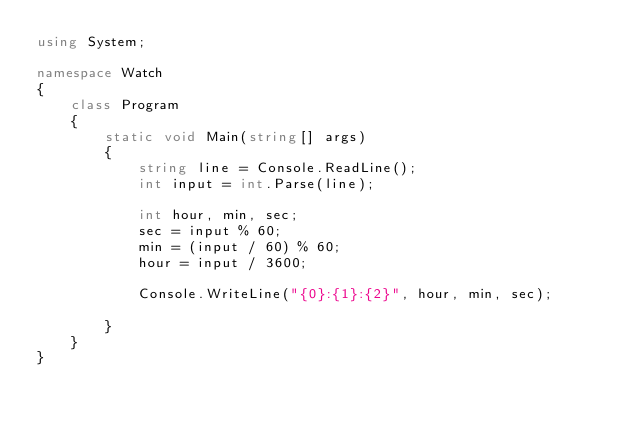<code> <loc_0><loc_0><loc_500><loc_500><_C#_>using System;

namespace Watch
{
    class Program
    {
        static void Main(string[] args)
        {
            string line = Console.ReadLine();
            int input = int.Parse(line);

            int hour, min, sec;
            sec = input % 60;
            min = (input / 60) % 60;
            hour = input / 3600;

            Console.WriteLine("{0}:{1}:{2}", hour, min, sec);

        }
    }
}</code> 